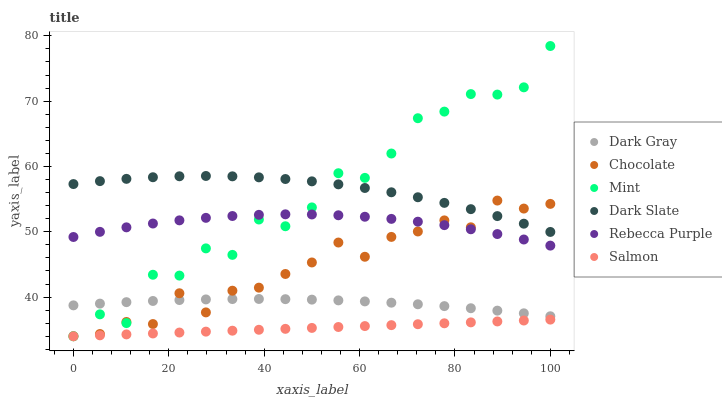Does Salmon have the minimum area under the curve?
Answer yes or no. Yes. Does Dark Slate have the maximum area under the curve?
Answer yes or no. Yes. Does Chocolate have the minimum area under the curve?
Answer yes or no. No. Does Chocolate have the maximum area under the curve?
Answer yes or no. No. Is Salmon the smoothest?
Answer yes or no. Yes. Is Mint the roughest?
Answer yes or no. Yes. Is Chocolate the smoothest?
Answer yes or no. No. Is Chocolate the roughest?
Answer yes or no. No. Does Salmon have the lowest value?
Answer yes or no. Yes. Does Dark Gray have the lowest value?
Answer yes or no. No. Does Mint have the highest value?
Answer yes or no. Yes. Does Chocolate have the highest value?
Answer yes or no. No. Is Rebecca Purple less than Dark Slate?
Answer yes or no. Yes. Is Dark Slate greater than Dark Gray?
Answer yes or no. Yes. Does Mint intersect Dark Gray?
Answer yes or no. Yes. Is Mint less than Dark Gray?
Answer yes or no. No. Is Mint greater than Dark Gray?
Answer yes or no. No. Does Rebecca Purple intersect Dark Slate?
Answer yes or no. No. 